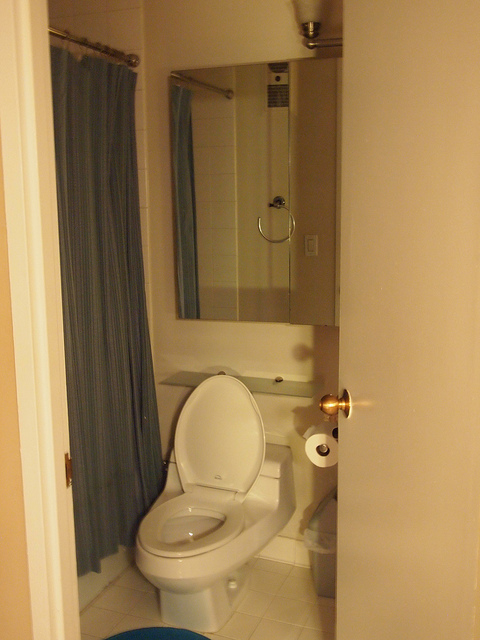<image>What shape is on the shower curtain? There is no specific shape on the shower curtain. However, it can be a rectangle or cones. What shape is on the shower curtain? It is unknown what shape is on the shower curtain. It can be seen as a rectangle, cones, or green. 